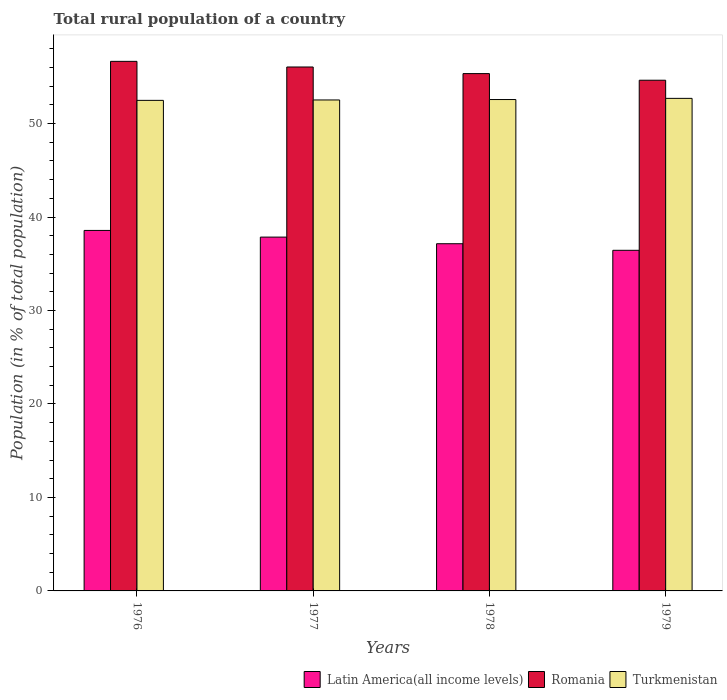How many different coloured bars are there?
Give a very brief answer. 3. Are the number of bars per tick equal to the number of legend labels?
Make the answer very short. Yes. How many bars are there on the 4th tick from the left?
Make the answer very short. 3. What is the rural population in Romania in 1976?
Your answer should be compact. 56.66. Across all years, what is the maximum rural population in Romania?
Keep it short and to the point. 56.66. Across all years, what is the minimum rural population in Romania?
Make the answer very short. 54.64. In which year was the rural population in Romania maximum?
Make the answer very short. 1976. In which year was the rural population in Romania minimum?
Offer a terse response. 1979. What is the total rural population in Turkmenistan in the graph?
Ensure brevity in your answer.  210.3. What is the difference between the rural population in Latin America(all income levels) in 1976 and that in 1979?
Ensure brevity in your answer.  2.13. What is the difference between the rural population in Romania in 1978 and the rural population in Turkmenistan in 1979?
Keep it short and to the point. 2.65. What is the average rural population in Romania per year?
Your response must be concise. 55.68. In the year 1976, what is the difference between the rural population in Latin America(all income levels) and rural population in Turkmenistan?
Ensure brevity in your answer.  -13.92. In how many years, is the rural population in Turkmenistan greater than 46 %?
Your answer should be compact. 4. What is the ratio of the rural population in Turkmenistan in 1978 to that in 1979?
Ensure brevity in your answer.  1. Is the rural population in Latin America(all income levels) in 1976 less than that in 1979?
Ensure brevity in your answer.  No. What is the difference between the highest and the second highest rural population in Romania?
Keep it short and to the point. 0.6. What is the difference between the highest and the lowest rural population in Turkmenistan?
Provide a succinct answer. 0.21. What does the 1st bar from the left in 1977 represents?
Your answer should be very brief. Latin America(all income levels). What does the 3rd bar from the right in 1978 represents?
Your answer should be compact. Latin America(all income levels). Are all the bars in the graph horizontal?
Provide a succinct answer. No. How many years are there in the graph?
Give a very brief answer. 4. What is the difference between two consecutive major ticks on the Y-axis?
Provide a short and direct response. 10. Does the graph contain any zero values?
Make the answer very short. No. Where does the legend appear in the graph?
Give a very brief answer. Bottom right. How are the legend labels stacked?
Offer a terse response. Horizontal. What is the title of the graph?
Your response must be concise. Total rural population of a country. Does "Central Europe" appear as one of the legend labels in the graph?
Offer a very short reply. No. What is the label or title of the X-axis?
Ensure brevity in your answer.  Years. What is the label or title of the Y-axis?
Your answer should be very brief. Population (in % of total population). What is the Population (in % of total population) of Latin America(all income levels) in 1976?
Give a very brief answer. 38.57. What is the Population (in % of total population) of Romania in 1976?
Your response must be concise. 56.66. What is the Population (in % of total population) in Turkmenistan in 1976?
Ensure brevity in your answer.  52.49. What is the Population (in % of total population) of Latin America(all income levels) in 1977?
Your answer should be very brief. 37.86. What is the Population (in % of total population) of Romania in 1977?
Give a very brief answer. 56.06. What is the Population (in % of total population) in Turkmenistan in 1977?
Give a very brief answer. 52.53. What is the Population (in % of total population) in Latin America(all income levels) in 1978?
Offer a very short reply. 37.15. What is the Population (in % of total population) in Romania in 1978?
Give a very brief answer. 55.35. What is the Population (in % of total population) of Turkmenistan in 1978?
Your response must be concise. 52.58. What is the Population (in % of total population) in Latin America(all income levels) in 1979?
Provide a succinct answer. 36.44. What is the Population (in % of total population) in Romania in 1979?
Offer a terse response. 54.64. What is the Population (in % of total population) of Turkmenistan in 1979?
Offer a very short reply. 52.7. Across all years, what is the maximum Population (in % of total population) of Latin America(all income levels)?
Give a very brief answer. 38.57. Across all years, what is the maximum Population (in % of total population) in Romania?
Provide a succinct answer. 56.66. Across all years, what is the maximum Population (in % of total population) in Turkmenistan?
Offer a very short reply. 52.7. Across all years, what is the minimum Population (in % of total population) in Latin America(all income levels)?
Offer a very short reply. 36.44. Across all years, what is the minimum Population (in % of total population) in Romania?
Your response must be concise. 54.64. Across all years, what is the minimum Population (in % of total population) in Turkmenistan?
Provide a succinct answer. 52.49. What is the total Population (in % of total population) of Latin America(all income levels) in the graph?
Keep it short and to the point. 150.02. What is the total Population (in % of total population) in Romania in the graph?
Make the answer very short. 222.71. What is the total Population (in % of total population) in Turkmenistan in the graph?
Your response must be concise. 210.29. What is the difference between the Population (in % of total population) of Latin America(all income levels) in 1976 and that in 1977?
Give a very brief answer. 0.71. What is the difference between the Population (in % of total population) of Romania in 1976 and that in 1977?
Offer a very short reply. 0.6. What is the difference between the Population (in % of total population) of Turkmenistan in 1976 and that in 1977?
Keep it short and to the point. -0.04. What is the difference between the Population (in % of total population) of Latin America(all income levels) in 1976 and that in 1978?
Offer a terse response. 1.42. What is the difference between the Population (in % of total population) of Romania in 1976 and that in 1978?
Ensure brevity in your answer.  1.31. What is the difference between the Population (in % of total population) in Turkmenistan in 1976 and that in 1978?
Offer a terse response. -0.09. What is the difference between the Population (in % of total population) in Latin America(all income levels) in 1976 and that in 1979?
Offer a very short reply. 2.13. What is the difference between the Population (in % of total population) in Romania in 1976 and that in 1979?
Provide a short and direct response. 2.02. What is the difference between the Population (in % of total population) in Turkmenistan in 1976 and that in 1979?
Ensure brevity in your answer.  -0.21. What is the difference between the Population (in % of total population) of Latin America(all income levels) in 1977 and that in 1978?
Your answer should be compact. 0.71. What is the difference between the Population (in % of total population) of Romania in 1977 and that in 1978?
Keep it short and to the point. 0.71. What is the difference between the Population (in % of total population) in Turkmenistan in 1977 and that in 1978?
Your answer should be compact. -0.04. What is the difference between the Population (in % of total population) in Latin America(all income levels) in 1977 and that in 1979?
Offer a terse response. 1.41. What is the difference between the Population (in % of total population) in Romania in 1977 and that in 1979?
Provide a short and direct response. 1.42. What is the difference between the Population (in % of total population) in Turkmenistan in 1977 and that in 1979?
Ensure brevity in your answer.  -0.17. What is the difference between the Population (in % of total population) of Latin America(all income levels) in 1978 and that in 1979?
Offer a terse response. 0.7. What is the difference between the Population (in % of total population) in Romania in 1978 and that in 1979?
Offer a terse response. 0.71. What is the difference between the Population (in % of total population) of Turkmenistan in 1978 and that in 1979?
Keep it short and to the point. -0.12. What is the difference between the Population (in % of total population) of Latin America(all income levels) in 1976 and the Population (in % of total population) of Romania in 1977?
Ensure brevity in your answer.  -17.49. What is the difference between the Population (in % of total population) in Latin America(all income levels) in 1976 and the Population (in % of total population) in Turkmenistan in 1977?
Your answer should be compact. -13.96. What is the difference between the Population (in % of total population) in Romania in 1976 and the Population (in % of total population) in Turkmenistan in 1977?
Offer a very short reply. 4.13. What is the difference between the Population (in % of total population) of Latin America(all income levels) in 1976 and the Population (in % of total population) of Romania in 1978?
Offer a very short reply. -16.78. What is the difference between the Population (in % of total population) of Latin America(all income levels) in 1976 and the Population (in % of total population) of Turkmenistan in 1978?
Give a very brief answer. -14.01. What is the difference between the Population (in % of total population) of Romania in 1976 and the Population (in % of total population) of Turkmenistan in 1978?
Offer a terse response. 4.08. What is the difference between the Population (in % of total population) of Latin America(all income levels) in 1976 and the Population (in % of total population) of Romania in 1979?
Provide a short and direct response. -16.07. What is the difference between the Population (in % of total population) in Latin America(all income levels) in 1976 and the Population (in % of total population) in Turkmenistan in 1979?
Provide a short and direct response. -14.13. What is the difference between the Population (in % of total population) of Romania in 1976 and the Population (in % of total population) of Turkmenistan in 1979?
Keep it short and to the point. 3.96. What is the difference between the Population (in % of total population) in Latin America(all income levels) in 1977 and the Population (in % of total population) in Romania in 1978?
Provide a short and direct response. -17.49. What is the difference between the Population (in % of total population) in Latin America(all income levels) in 1977 and the Population (in % of total population) in Turkmenistan in 1978?
Make the answer very short. -14.72. What is the difference between the Population (in % of total population) in Romania in 1977 and the Population (in % of total population) in Turkmenistan in 1978?
Offer a very short reply. 3.48. What is the difference between the Population (in % of total population) in Latin America(all income levels) in 1977 and the Population (in % of total population) in Romania in 1979?
Ensure brevity in your answer.  -16.78. What is the difference between the Population (in % of total population) in Latin America(all income levels) in 1977 and the Population (in % of total population) in Turkmenistan in 1979?
Offer a terse response. -14.84. What is the difference between the Population (in % of total population) of Romania in 1977 and the Population (in % of total population) of Turkmenistan in 1979?
Make the answer very short. 3.36. What is the difference between the Population (in % of total population) of Latin America(all income levels) in 1978 and the Population (in % of total population) of Romania in 1979?
Make the answer very short. -17.49. What is the difference between the Population (in % of total population) in Latin America(all income levels) in 1978 and the Population (in % of total population) in Turkmenistan in 1979?
Your response must be concise. -15.55. What is the difference between the Population (in % of total population) in Romania in 1978 and the Population (in % of total population) in Turkmenistan in 1979?
Provide a succinct answer. 2.65. What is the average Population (in % of total population) of Latin America(all income levels) per year?
Ensure brevity in your answer.  37.5. What is the average Population (in % of total population) in Romania per year?
Give a very brief answer. 55.68. What is the average Population (in % of total population) of Turkmenistan per year?
Your response must be concise. 52.57. In the year 1976, what is the difference between the Population (in % of total population) of Latin America(all income levels) and Population (in % of total population) of Romania?
Keep it short and to the point. -18.09. In the year 1976, what is the difference between the Population (in % of total population) of Latin America(all income levels) and Population (in % of total population) of Turkmenistan?
Keep it short and to the point. -13.92. In the year 1976, what is the difference between the Population (in % of total population) of Romania and Population (in % of total population) of Turkmenistan?
Provide a succinct answer. 4.17. In the year 1977, what is the difference between the Population (in % of total population) of Latin America(all income levels) and Population (in % of total population) of Romania?
Keep it short and to the point. -18.2. In the year 1977, what is the difference between the Population (in % of total population) of Latin America(all income levels) and Population (in % of total population) of Turkmenistan?
Give a very brief answer. -14.67. In the year 1977, what is the difference between the Population (in % of total population) of Romania and Population (in % of total population) of Turkmenistan?
Your response must be concise. 3.53. In the year 1978, what is the difference between the Population (in % of total population) of Latin America(all income levels) and Population (in % of total population) of Romania?
Your answer should be compact. -18.2. In the year 1978, what is the difference between the Population (in % of total population) of Latin America(all income levels) and Population (in % of total population) of Turkmenistan?
Give a very brief answer. -15.43. In the year 1978, what is the difference between the Population (in % of total population) of Romania and Population (in % of total population) of Turkmenistan?
Make the answer very short. 2.77. In the year 1979, what is the difference between the Population (in % of total population) of Latin America(all income levels) and Population (in % of total population) of Romania?
Your answer should be very brief. -18.2. In the year 1979, what is the difference between the Population (in % of total population) in Latin America(all income levels) and Population (in % of total population) in Turkmenistan?
Your answer should be compact. -16.26. In the year 1979, what is the difference between the Population (in % of total population) of Romania and Population (in % of total population) of Turkmenistan?
Ensure brevity in your answer.  1.94. What is the ratio of the Population (in % of total population) in Latin America(all income levels) in 1976 to that in 1977?
Give a very brief answer. 1.02. What is the ratio of the Population (in % of total population) of Romania in 1976 to that in 1977?
Keep it short and to the point. 1.01. What is the ratio of the Population (in % of total population) in Latin America(all income levels) in 1976 to that in 1978?
Provide a succinct answer. 1.04. What is the ratio of the Population (in % of total population) in Romania in 1976 to that in 1978?
Your answer should be very brief. 1.02. What is the ratio of the Population (in % of total population) of Latin America(all income levels) in 1976 to that in 1979?
Ensure brevity in your answer.  1.06. What is the ratio of the Population (in % of total population) in Romania in 1976 to that in 1979?
Keep it short and to the point. 1.04. What is the ratio of the Population (in % of total population) of Latin America(all income levels) in 1977 to that in 1978?
Provide a succinct answer. 1.02. What is the ratio of the Population (in % of total population) of Romania in 1977 to that in 1978?
Your answer should be very brief. 1.01. What is the ratio of the Population (in % of total population) in Turkmenistan in 1977 to that in 1978?
Provide a succinct answer. 1. What is the ratio of the Population (in % of total population) of Latin America(all income levels) in 1977 to that in 1979?
Provide a short and direct response. 1.04. What is the ratio of the Population (in % of total population) of Romania in 1977 to that in 1979?
Your answer should be compact. 1.03. What is the ratio of the Population (in % of total population) of Latin America(all income levels) in 1978 to that in 1979?
Your response must be concise. 1.02. What is the ratio of the Population (in % of total population) in Romania in 1978 to that in 1979?
Provide a succinct answer. 1.01. What is the difference between the highest and the second highest Population (in % of total population) of Latin America(all income levels)?
Give a very brief answer. 0.71. What is the difference between the highest and the second highest Population (in % of total population) in Romania?
Ensure brevity in your answer.  0.6. What is the difference between the highest and the second highest Population (in % of total population) in Turkmenistan?
Ensure brevity in your answer.  0.12. What is the difference between the highest and the lowest Population (in % of total population) of Latin America(all income levels)?
Make the answer very short. 2.13. What is the difference between the highest and the lowest Population (in % of total population) of Romania?
Make the answer very short. 2.02. What is the difference between the highest and the lowest Population (in % of total population) in Turkmenistan?
Provide a succinct answer. 0.21. 